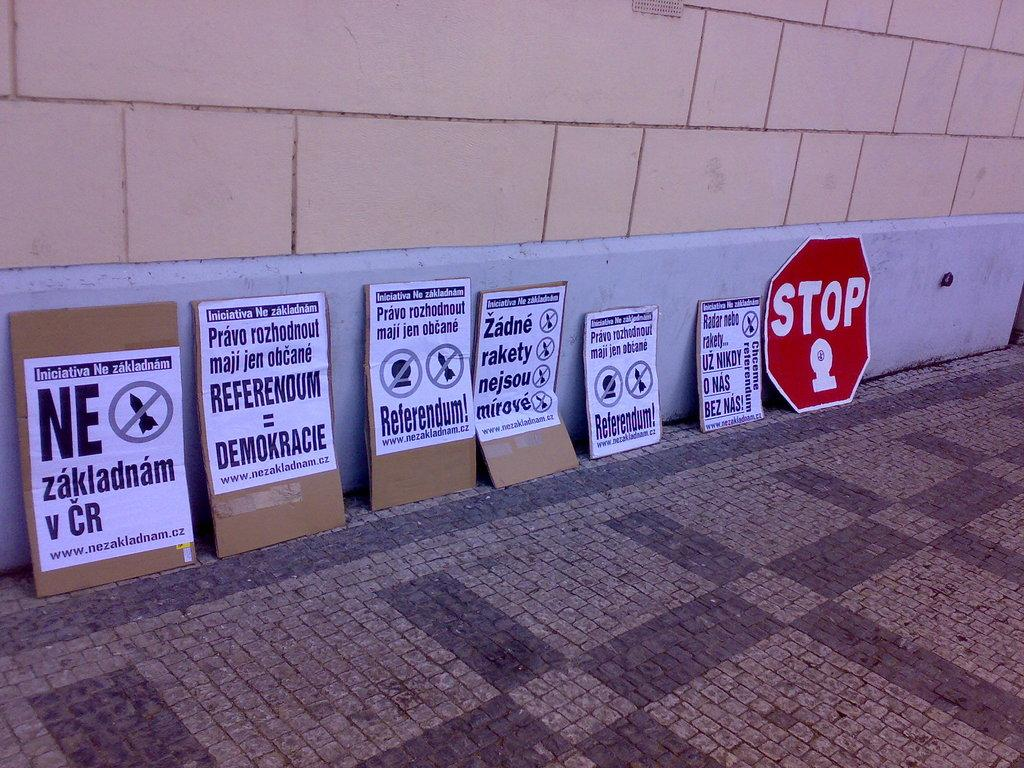What can be seen on the sign boards in the image? Papers are attached to the sign boards in the image. What is written on the papers? There is writing on the papers. What is the background of the image? There is a wall visible in the image. How many fingers are visible on the sign boards in the image? There are no fingers visible on the sign boards in the image. Is there a birthday celebration happening in the image? There is no indication of a birthday celebration in the image. 